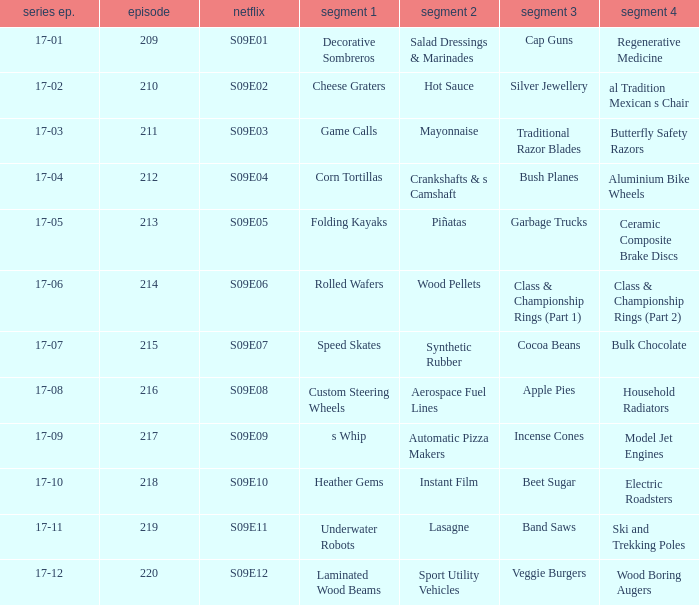How many segments involve wood boring augers Laminated Wood Beams. 